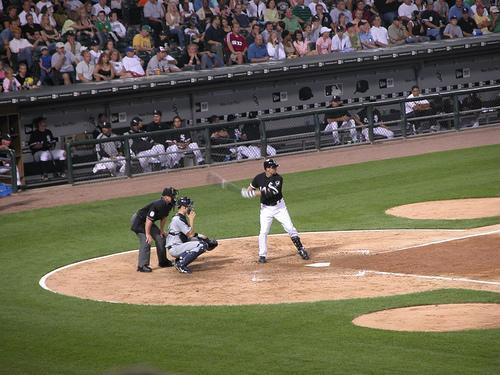How many red shirts are there?
Give a very brief answer. 1. How many people are there?
Give a very brief answer. 4. 